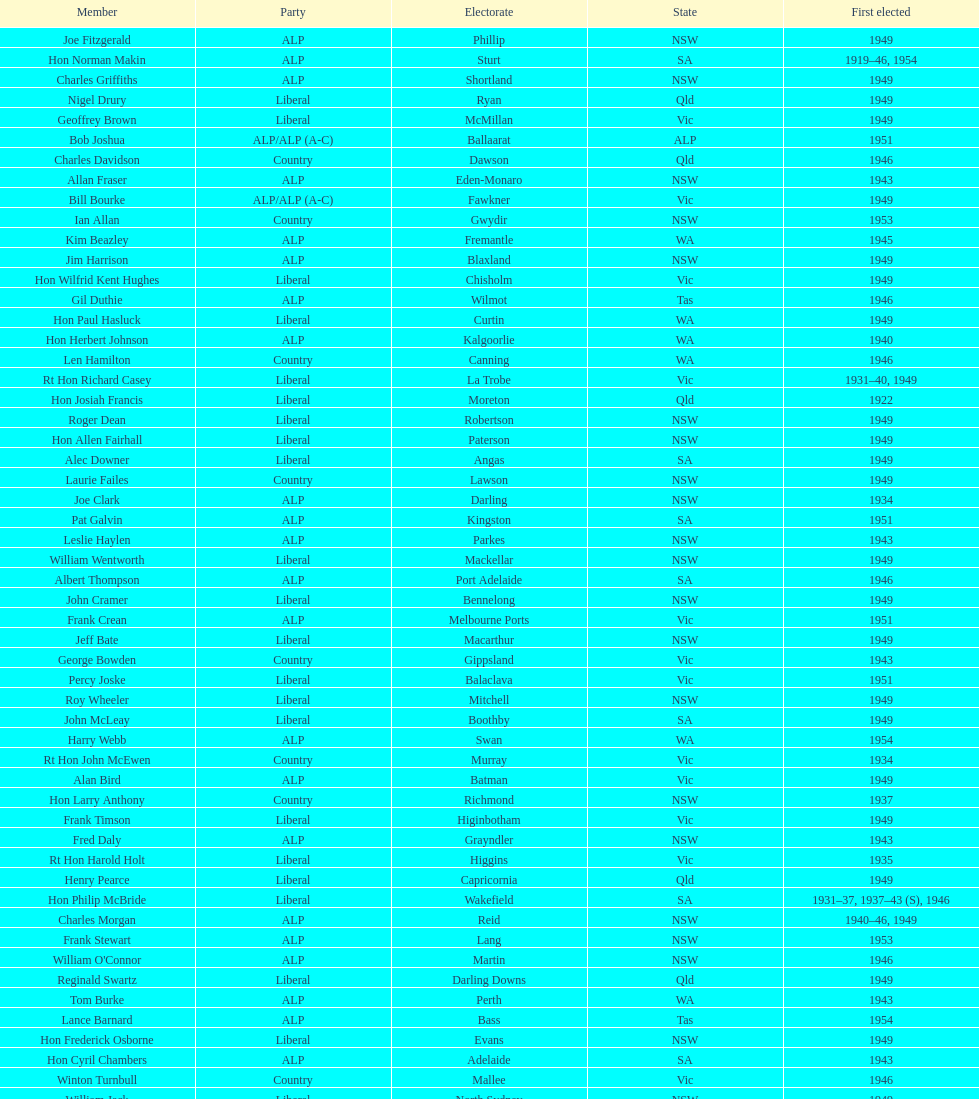Did tom burke run as country or alp party? ALP. 